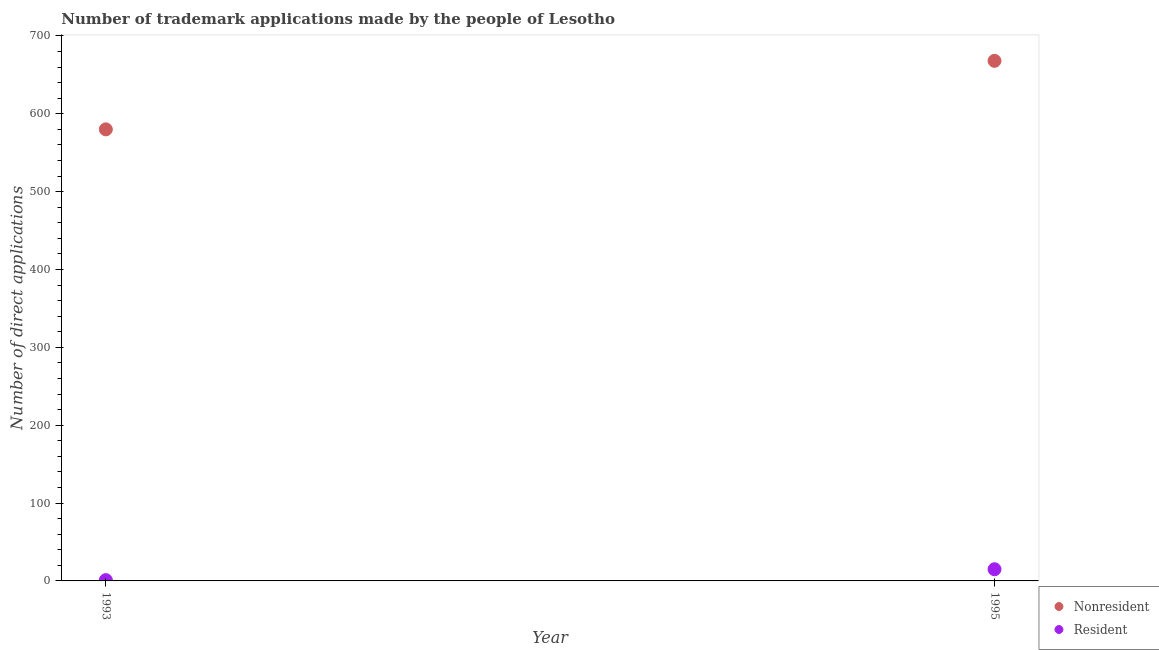How many different coloured dotlines are there?
Your answer should be compact. 2. Is the number of dotlines equal to the number of legend labels?
Offer a terse response. Yes. What is the number of trademark applications made by non residents in 1995?
Provide a succinct answer. 668. Across all years, what is the maximum number of trademark applications made by non residents?
Your answer should be very brief. 668. Across all years, what is the minimum number of trademark applications made by residents?
Your response must be concise. 1. In which year was the number of trademark applications made by non residents maximum?
Offer a very short reply. 1995. In which year was the number of trademark applications made by non residents minimum?
Your answer should be very brief. 1993. What is the total number of trademark applications made by non residents in the graph?
Provide a short and direct response. 1248. What is the difference between the number of trademark applications made by non residents in 1993 and that in 1995?
Provide a succinct answer. -88. What is the difference between the number of trademark applications made by non residents in 1993 and the number of trademark applications made by residents in 1995?
Provide a succinct answer. 565. What is the average number of trademark applications made by non residents per year?
Make the answer very short. 624. In the year 1993, what is the difference between the number of trademark applications made by residents and number of trademark applications made by non residents?
Your answer should be compact. -579. In how many years, is the number of trademark applications made by non residents greater than 500?
Offer a terse response. 2. What is the ratio of the number of trademark applications made by residents in 1993 to that in 1995?
Your answer should be very brief. 0.07. Is the number of trademark applications made by residents in 1993 less than that in 1995?
Keep it short and to the point. Yes. Is the number of trademark applications made by non residents strictly greater than the number of trademark applications made by residents over the years?
Your response must be concise. Yes. Is the number of trademark applications made by non residents strictly less than the number of trademark applications made by residents over the years?
Offer a very short reply. No. How many years are there in the graph?
Offer a terse response. 2. What is the difference between two consecutive major ticks on the Y-axis?
Make the answer very short. 100. Are the values on the major ticks of Y-axis written in scientific E-notation?
Make the answer very short. No. Does the graph contain grids?
Ensure brevity in your answer.  No. Where does the legend appear in the graph?
Your answer should be very brief. Bottom right. How many legend labels are there?
Provide a succinct answer. 2. What is the title of the graph?
Give a very brief answer. Number of trademark applications made by the people of Lesotho. Does "Tetanus" appear as one of the legend labels in the graph?
Provide a short and direct response. No. What is the label or title of the Y-axis?
Keep it short and to the point. Number of direct applications. What is the Number of direct applications in Nonresident in 1993?
Your response must be concise. 580. What is the Number of direct applications in Nonresident in 1995?
Ensure brevity in your answer.  668. Across all years, what is the maximum Number of direct applications of Nonresident?
Offer a very short reply. 668. Across all years, what is the maximum Number of direct applications of Resident?
Ensure brevity in your answer.  15. Across all years, what is the minimum Number of direct applications of Nonresident?
Ensure brevity in your answer.  580. Across all years, what is the minimum Number of direct applications of Resident?
Give a very brief answer. 1. What is the total Number of direct applications of Nonresident in the graph?
Your answer should be compact. 1248. What is the total Number of direct applications of Resident in the graph?
Offer a terse response. 16. What is the difference between the Number of direct applications of Nonresident in 1993 and that in 1995?
Keep it short and to the point. -88. What is the difference between the Number of direct applications in Resident in 1993 and that in 1995?
Provide a short and direct response. -14. What is the difference between the Number of direct applications in Nonresident in 1993 and the Number of direct applications in Resident in 1995?
Offer a very short reply. 565. What is the average Number of direct applications of Nonresident per year?
Provide a short and direct response. 624. In the year 1993, what is the difference between the Number of direct applications of Nonresident and Number of direct applications of Resident?
Keep it short and to the point. 579. In the year 1995, what is the difference between the Number of direct applications in Nonresident and Number of direct applications in Resident?
Your answer should be very brief. 653. What is the ratio of the Number of direct applications of Nonresident in 1993 to that in 1995?
Ensure brevity in your answer.  0.87. What is the ratio of the Number of direct applications in Resident in 1993 to that in 1995?
Give a very brief answer. 0.07. What is the difference between the highest and the second highest Number of direct applications of Nonresident?
Your answer should be very brief. 88. What is the difference between the highest and the second highest Number of direct applications in Resident?
Ensure brevity in your answer.  14. What is the difference between the highest and the lowest Number of direct applications in Nonresident?
Provide a succinct answer. 88. 